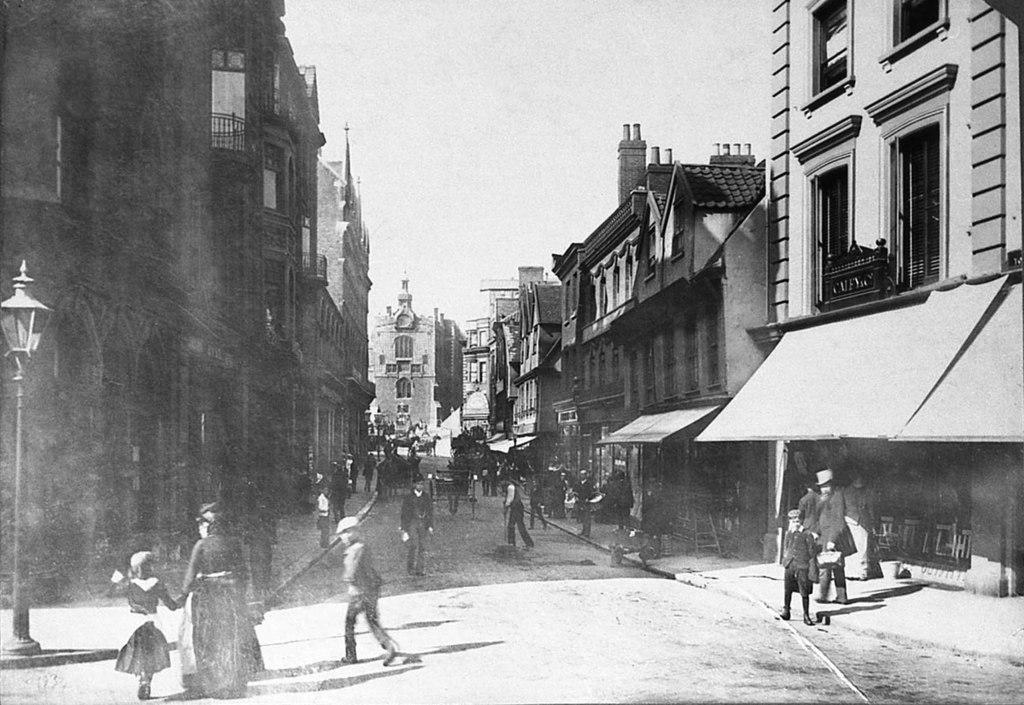What can be seen in the image involving people? There are people standing in the image. What object is present in the image that might be used for support or guidance? There is a pole in the image. What can be seen in the image that provides illumination? There is a light in the image. What type of structures are visible in the image? There are buildings in the image. What visual effect can be observed due to the presence of light and shadows in the image? Shadows are visible in the image. How is the image presented in terms of color? The image is black and white in color. What type of brush is being used by the people in the image? There is no brush visible in the image; the people are simply standing. What type of shock can be seen in the image? There is no shock present in the image; it is a static scene with people standing. 